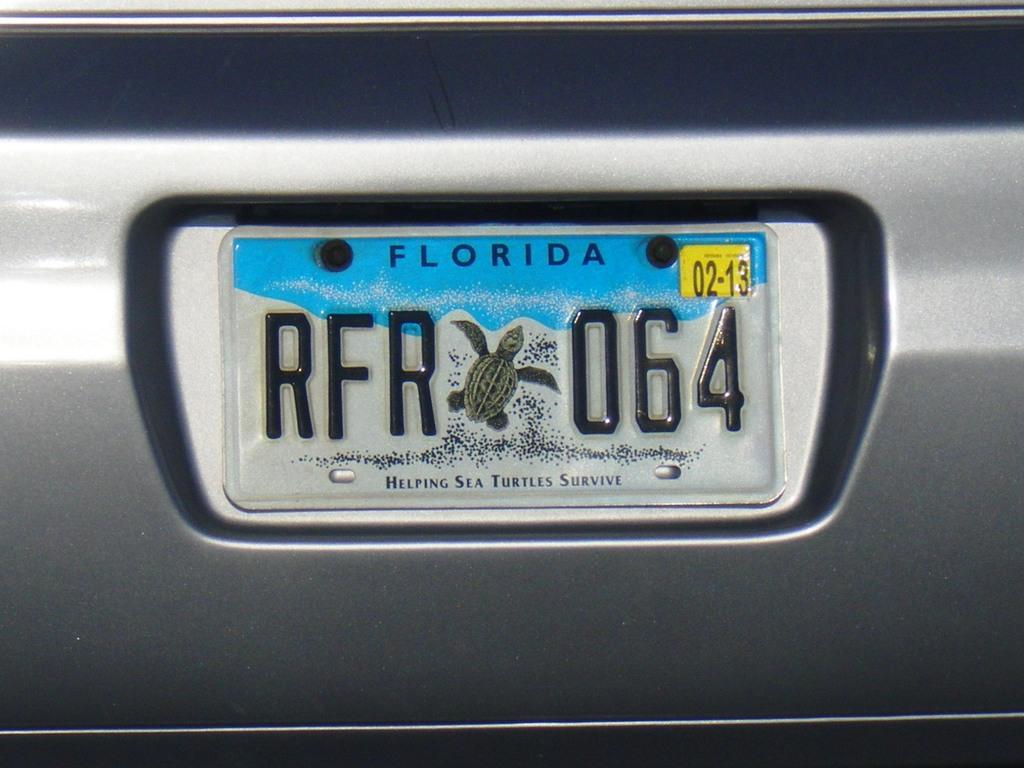When does this tag expire?
Offer a terse response. 02-13. What state is this license plate from?
Ensure brevity in your answer.  Florida. 